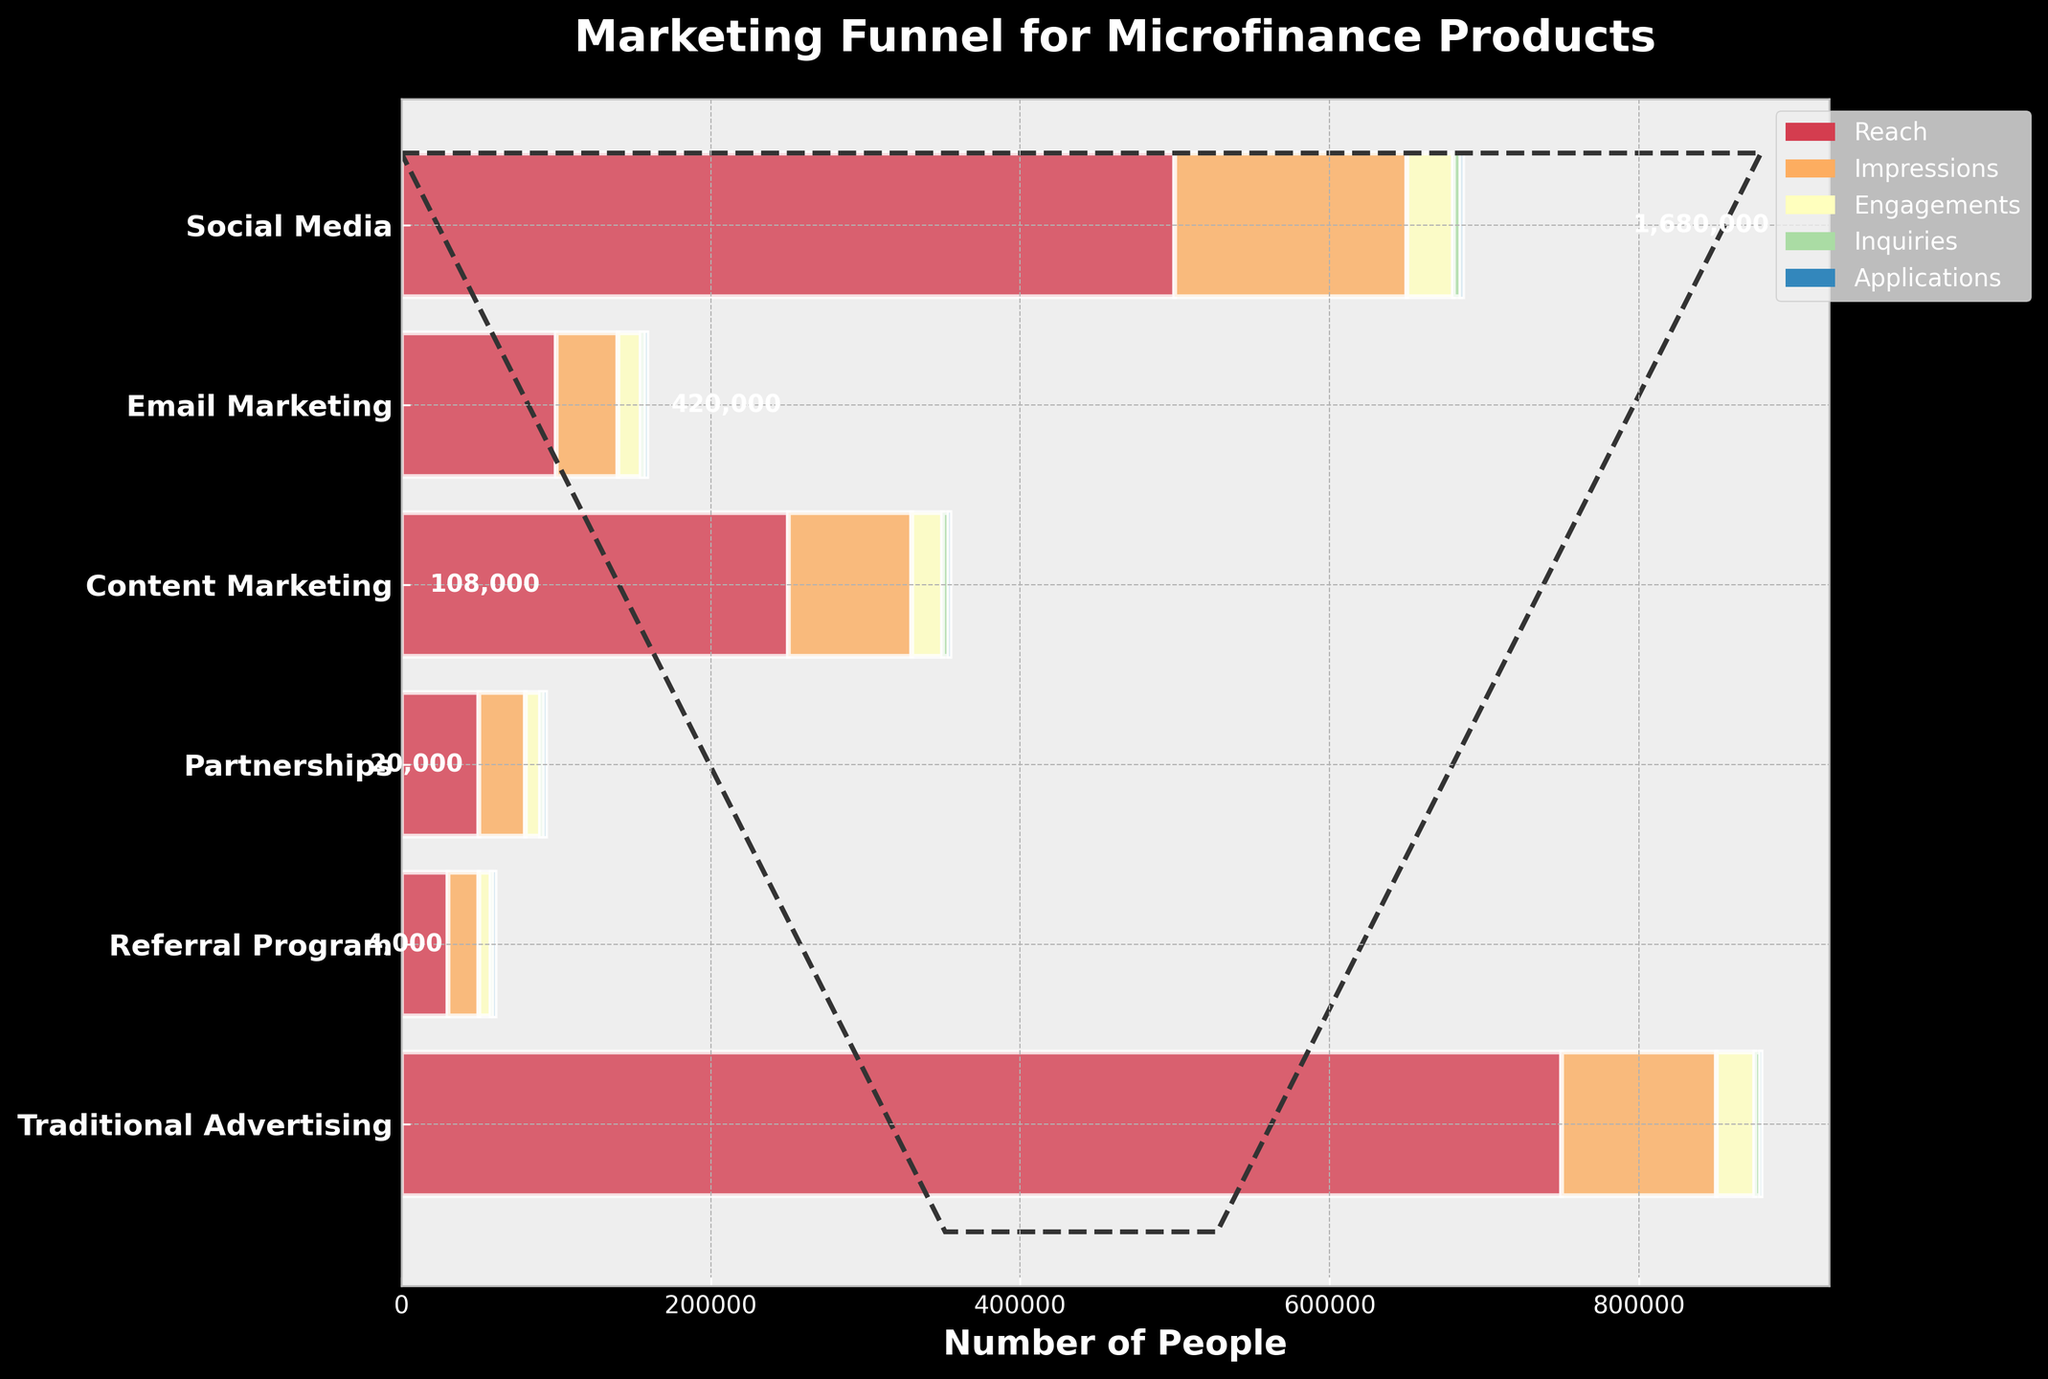What's the title of the figure? The title of the figure is located at the top and often gives an overview of what the chart is about.
Answer: Marketing Funnel for Microfinance Products How many marketing channels are displayed in the figure? The number of marketing channels can be counted along the y-axis, which lists the channels.
Answer: 6 Which channel has the highest reach? The channel with the highest reach will have the longest bar segment for the "Reach" category.
Answer: Traditional Advertising What's the total number of inquiries across all channels? Sum the total inquiries from each channel: 5000 (Social Media) + 3000 (Email Marketing) + 4000 (Content Marketing) + 2500 (Partnerships) + 2000 (Referral Program) + 3500 (Traditional Advertising).
Answer: 20,000 How does the number of engagements in Social Media compare to Email Marketing? Look at the lengths of the bars for "Engagements" for both Social Media and Email Marketing. Compare their values: 30,000 (Social Media) vs. 15,000 (Email Marketing).
Answer: Social Media has twice the engagements as Email Marketing Which channel has the least number of applications and what is that number? The least number of applications will be the shortest bar segment in the "Applications" category.
Answer: Traditional Advertising with 400 applications What's the difference in the number of impressions between Social Media and Content Marketing? Subtract the impressions of Content Marketing from those of Social Media: 150,000 - 80,000.
Answer: 70,000 How does the number of inquiries from Partnerships compare to that of Referral Program? Compare the lengths of the bars for "Inquiries" for both Partnerships and Referral Program.
Answer: Partnerships has 500 more inquiries than Referral Program If you sum the applications for Email Marketing and Content Marketing, what do you get? Add the applications from Email Marketing and Content Marketing: 800 + 600.
Answer: 1,400 What percentage of engagements translate into inquiries for Social Media? Divide the number of inquiries by the number of engagements, and then multiply by 100: (5000 / 30000) * 100.
Answer: 16.7% 